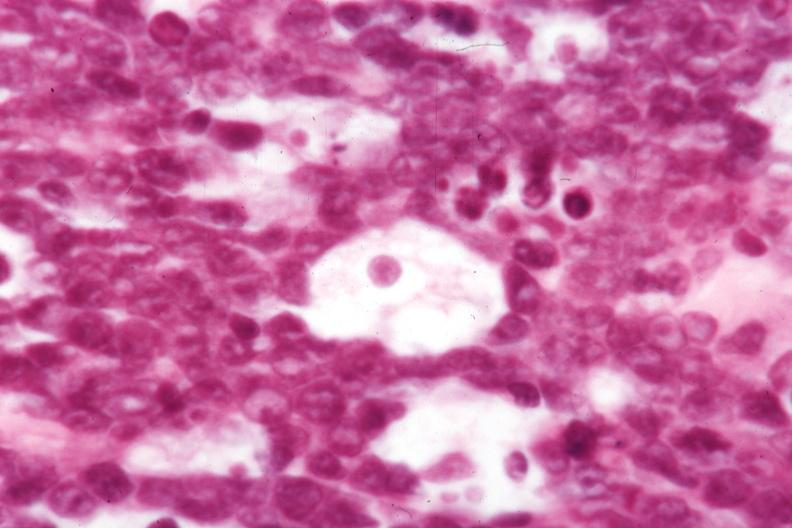what is present?
Answer the question using a single word or phrase. Burkitts lymphoma 